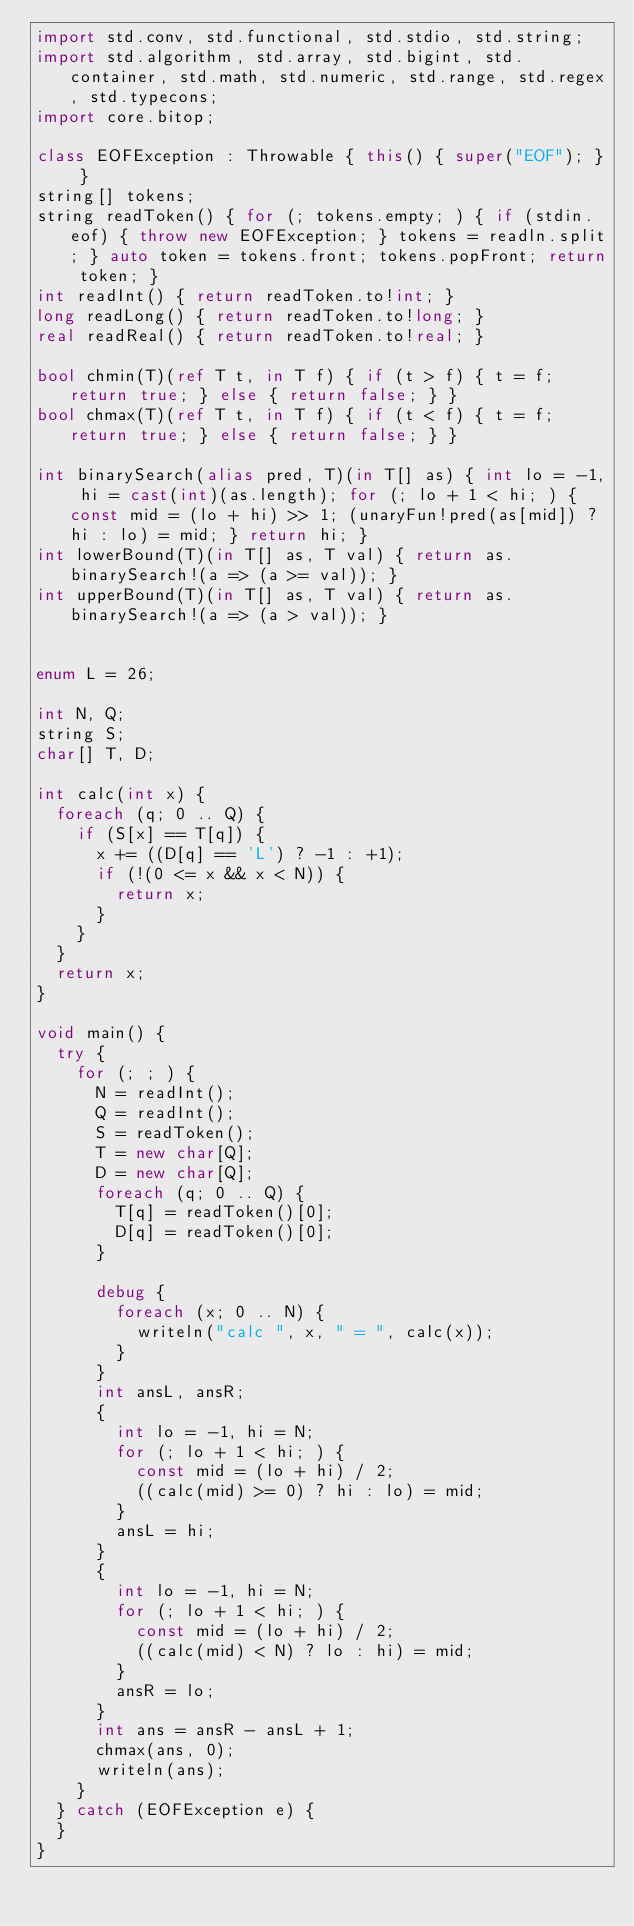<code> <loc_0><loc_0><loc_500><loc_500><_D_>import std.conv, std.functional, std.stdio, std.string;
import std.algorithm, std.array, std.bigint, std.container, std.math, std.numeric, std.range, std.regex, std.typecons;
import core.bitop;

class EOFException : Throwable { this() { super("EOF"); } }
string[] tokens;
string readToken() { for (; tokens.empty; ) { if (stdin.eof) { throw new EOFException; } tokens = readln.split; } auto token = tokens.front; tokens.popFront; return token; }
int readInt() { return readToken.to!int; }
long readLong() { return readToken.to!long; }
real readReal() { return readToken.to!real; }

bool chmin(T)(ref T t, in T f) { if (t > f) { t = f; return true; } else { return false; } }
bool chmax(T)(ref T t, in T f) { if (t < f) { t = f; return true; } else { return false; } }

int binarySearch(alias pred, T)(in T[] as) { int lo = -1, hi = cast(int)(as.length); for (; lo + 1 < hi; ) { const mid = (lo + hi) >> 1; (unaryFun!pred(as[mid]) ? hi : lo) = mid; } return hi; }
int lowerBound(T)(in T[] as, T val) { return as.binarySearch!(a => (a >= val)); }
int upperBound(T)(in T[] as, T val) { return as.binarySearch!(a => (a > val)); }


enum L = 26;

int N, Q;
string S;
char[] T, D;

int calc(int x) {
  foreach (q; 0 .. Q) {
    if (S[x] == T[q]) {
      x += ((D[q] == 'L') ? -1 : +1);
      if (!(0 <= x && x < N)) {
        return x;
      }
    }
  }
  return x;
}

void main() {
  try {
    for (; ; ) {
      N = readInt();
      Q = readInt();
      S = readToken();
      T = new char[Q];
      D = new char[Q];
      foreach (q; 0 .. Q) {
        T[q] = readToken()[0];
        D[q] = readToken()[0];
      }
      
      debug {
        foreach (x; 0 .. N) {
          writeln("calc ", x, " = ", calc(x));
        }
      }
      int ansL, ansR;
      {
        int lo = -1, hi = N;
        for (; lo + 1 < hi; ) {
          const mid = (lo + hi) / 2;
          ((calc(mid) >= 0) ? hi : lo) = mid;
        }
        ansL = hi;
      }
      {
        int lo = -1, hi = N;
        for (; lo + 1 < hi; ) {
          const mid = (lo + hi) / 2;
          ((calc(mid) < N) ? lo : hi) = mid;
        }
        ansR = lo;
      }
      int ans = ansR - ansL + 1;
      chmax(ans, 0);
      writeln(ans);
    }
  } catch (EOFException e) {
  }
}
</code> 